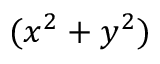<formula> <loc_0><loc_0><loc_500><loc_500>( x ^ { 2 } + y ^ { 2 } )</formula> 